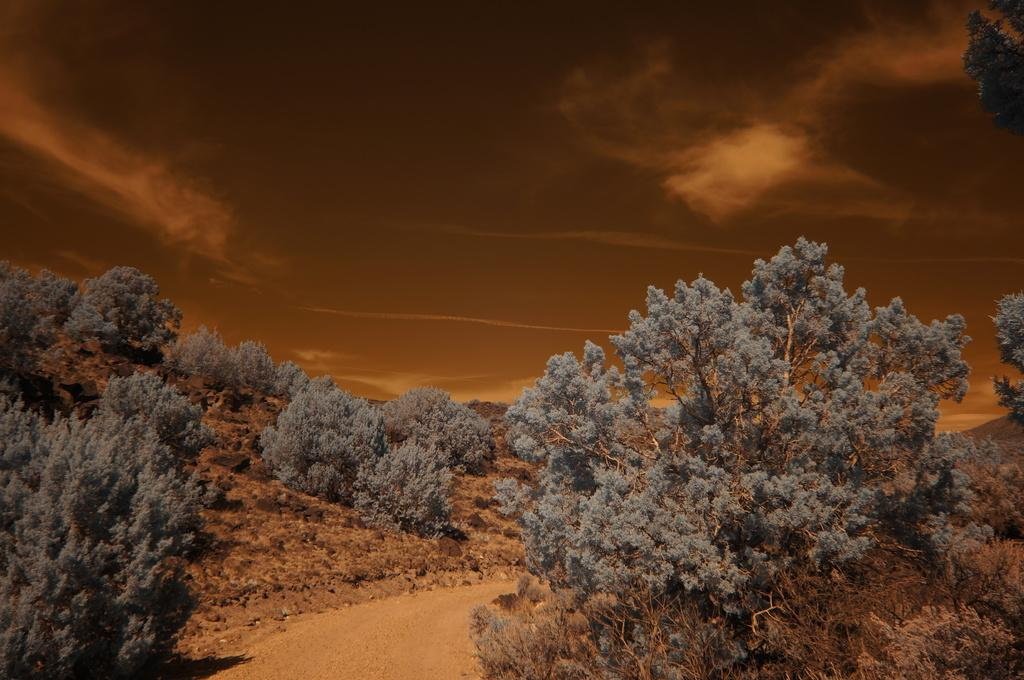What type of vegetation can be seen in the image? There are trees in the image. What is located at the bottom of the image? There is a walkway at the bottom of the image. What can be seen in the background of the image? The sky is visible in the background of the image. How many passengers are visible in the image? There are no passengers present in the image. What type of pot is being used by the trees in the image? There is no pot present in the image; it features trees and a walkway. 